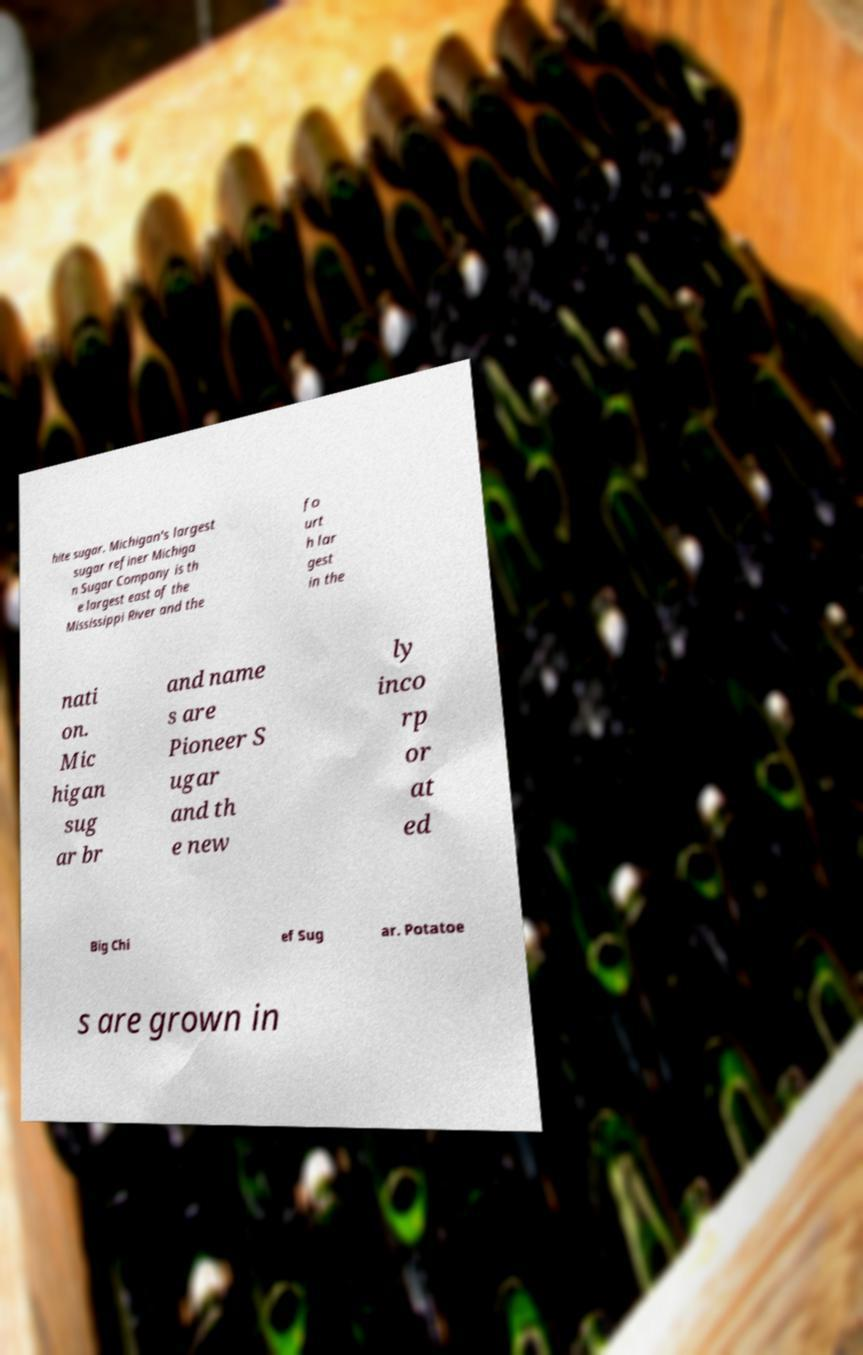Please identify and transcribe the text found in this image. hite sugar. Michigan's largest sugar refiner Michiga n Sugar Company is th e largest east of the Mississippi River and the fo urt h lar gest in the nati on. Mic higan sug ar br and name s are Pioneer S ugar and th e new ly inco rp or at ed Big Chi ef Sug ar. Potatoe s are grown in 